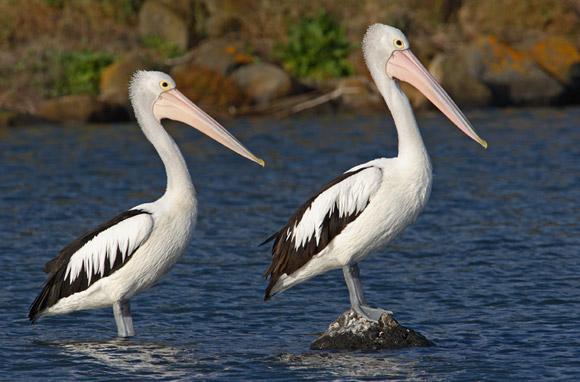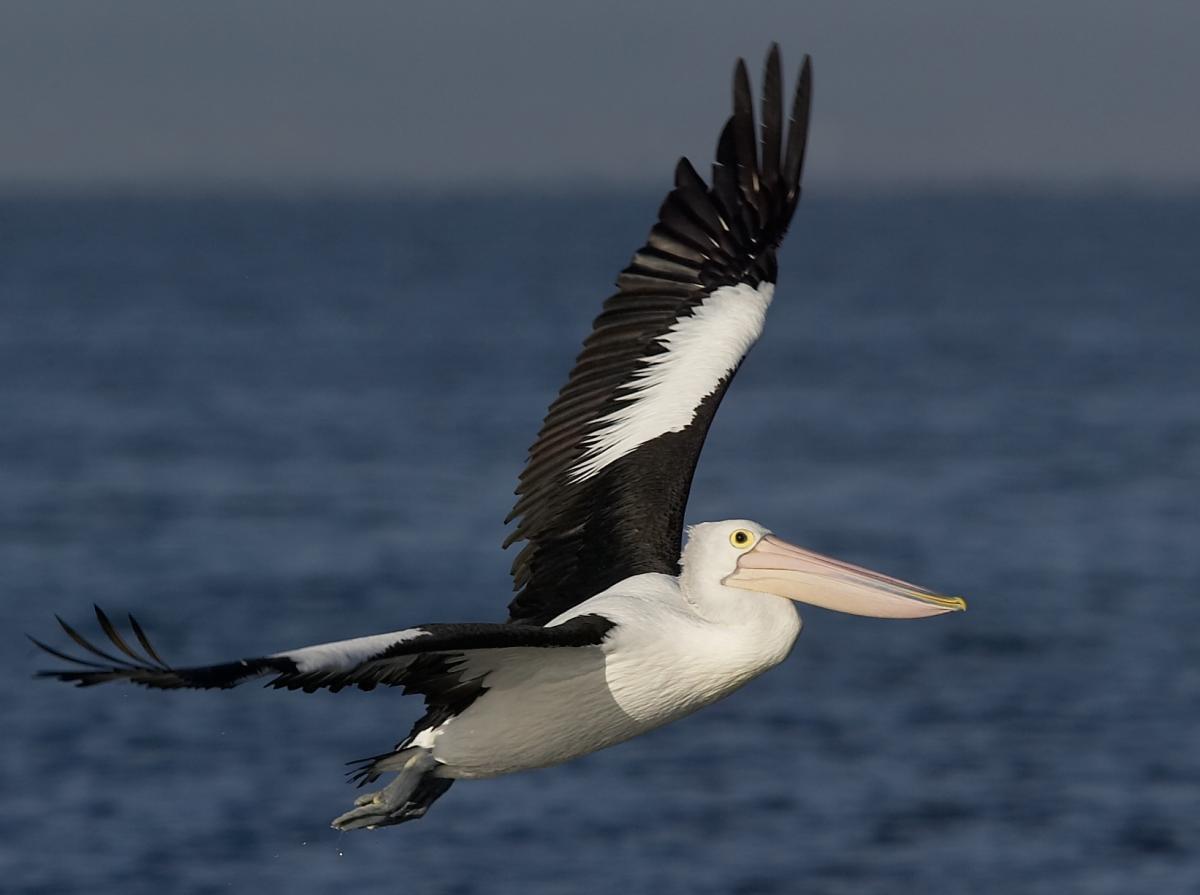The first image is the image on the left, the second image is the image on the right. Assess this claim about the two images: "One image shows a pelican in flight.". Correct or not? Answer yes or no. Yes. 